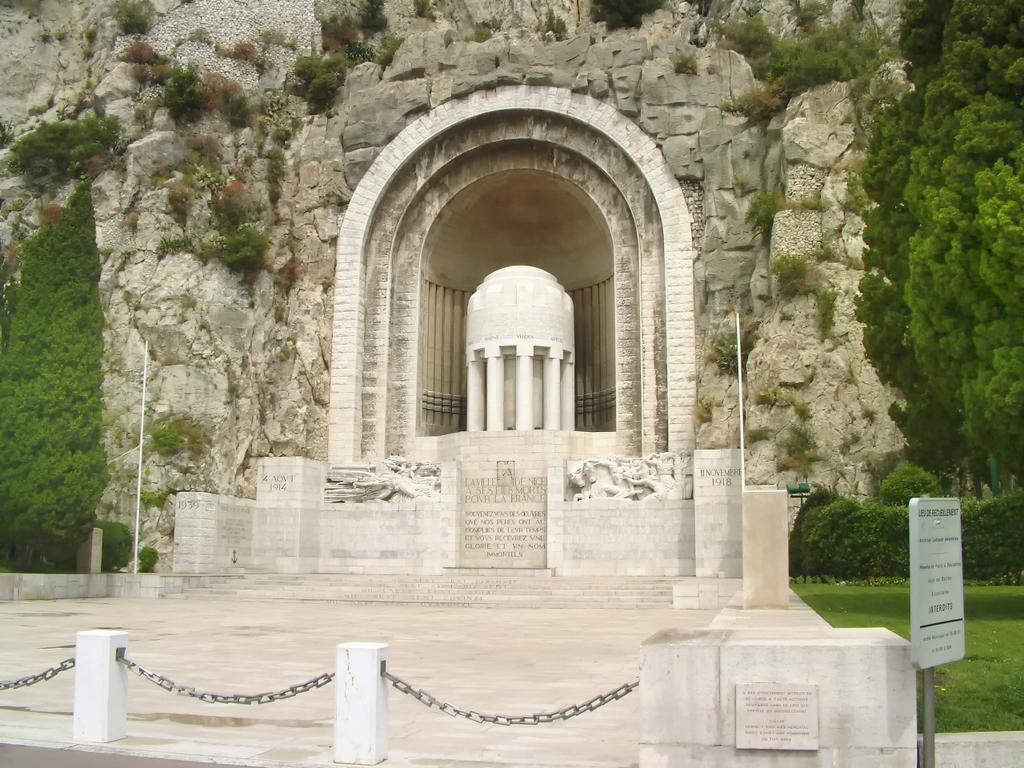What type of structure is shown in the image? The image depicts a fort. What can be seen in the background of the image? There are trees, bushes, stairs, and poles in the background. What is the purpose of the fence in the image? The fence is likely used to enclose or protect the fort. What is the board used for in the image? The purpose of the board is not clear from the image, but it could be used for signage or as a barrier. What is visible at the bottom of the image? The ground is visible at the bottom of the image. How many cows can be seen grazing in the background of the image? There are no cows present in the image; it depicts a fort with various background elements. What type of cloud formation can be seen in the image? There are no clouds visible in the image; it shows a fort with a clear sky in the background. 